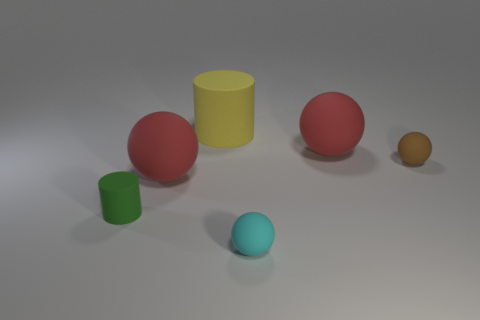Add 1 big gray cubes. How many objects exist? 7 Subtract all cyan balls. How many balls are left? 3 Add 3 red balls. How many red balls are left? 5 Add 3 big cylinders. How many big cylinders exist? 4 Subtract 1 cyan balls. How many objects are left? 5 Subtract all spheres. How many objects are left? 2 Subtract 4 spheres. How many spheres are left? 0 Subtract all red balls. Subtract all gray cylinders. How many balls are left? 2 Subtract all green blocks. How many cyan balls are left? 1 Subtract all small spheres. Subtract all cylinders. How many objects are left? 2 